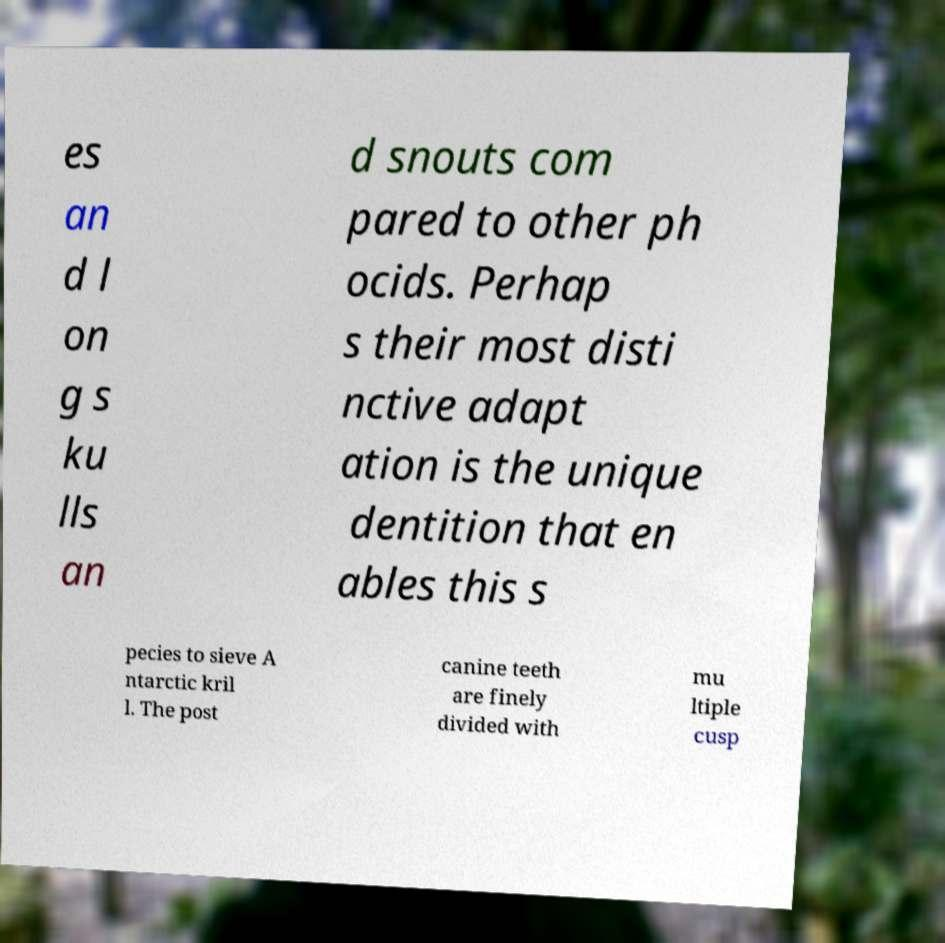Could you extract and type out the text from this image? es an d l on g s ku lls an d snouts com pared to other ph ocids. Perhap s their most disti nctive adapt ation is the unique dentition that en ables this s pecies to sieve A ntarctic kril l. The post canine teeth are finely divided with mu ltiple cusp 